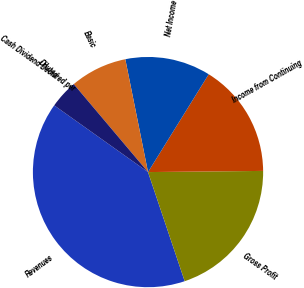Convert chart to OTSL. <chart><loc_0><loc_0><loc_500><loc_500><pie_chart><fcel>Revenues<fcel>Gross Profit<fcel>Income from Continuing<fcel>Net Income<fcel>Basic<fcel>Diluted<fcel>Cash Dividend Declared per<nl><fcel>40.0%<fcel>20.0%<fcel>16.0%<fcel>12.0%<fcel>8.0%<fcel>4.0%<fcel>0.0%<nl></chart> 